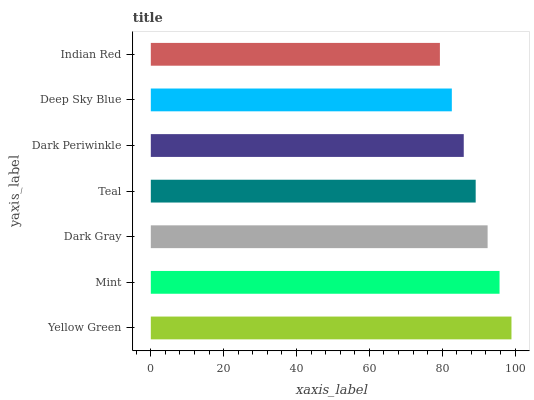Is Indian Red the minimum?
Answer yes or no. Yes. Is Yellow Green the maximum?
Answer yes or no. Yes. Is Mint the minimum?
Answer yes or no. No. Is Mint the maximum?
Answer yes or no. No. Is Yellow Green greater than Mint?
Answer yes or no. Yes. Is Mint less than Yellow Green?
Answer yes or no. Yes. Is Mint greater than Yellow Green?
Answer yes or no. No. Is Yellow Green less than Mint?
Answer yes or no. No. Is Teal the high median?
Answer yes or no. Yes. Is Teal the low median?
Answer yes or no. Yes. Is Mint the high median?
Answer yes or no. No. Is Indian Red the low median?
Answer yes or no. No. 